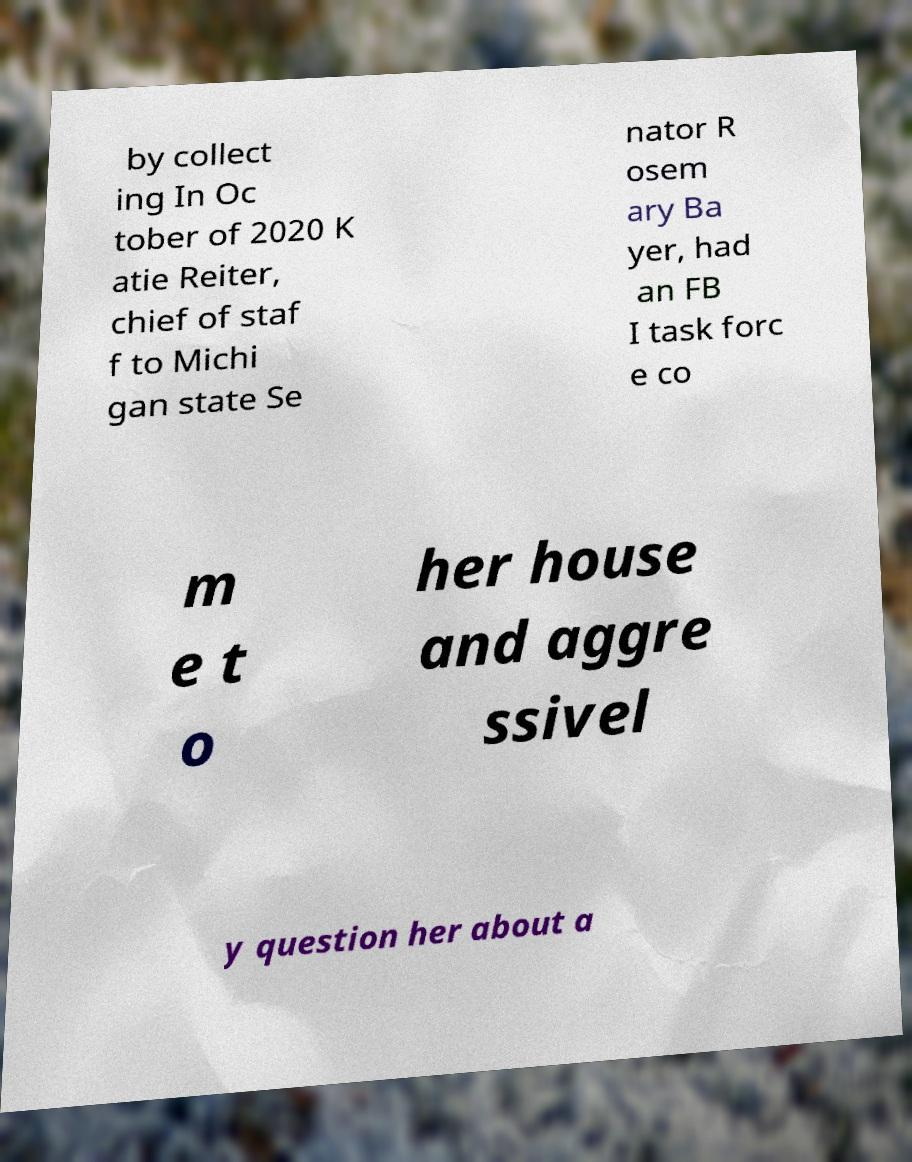Please identify and transcribe the text found in this image. by collect ing In Oc tober of 2020 K atie Reiter, chief of staf f to Michi gan state Se nator R osem ary Ba yer, had an FB I task forc e co m e t o her house and aggre ssivel y question her about a 